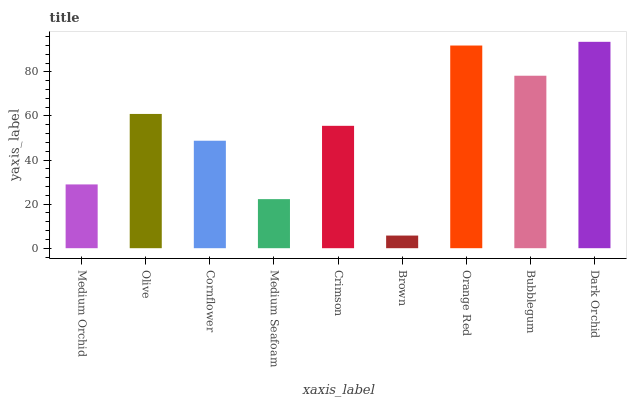Is Brown the minimum?
Answer yes or no. Yes. Is Dark Orchid the maximum?
Answer yes or no. Yes. Is Olive the minimum?
Answer yes or no. No. Is Olive the maximum?
Answer yes or no. No. Is Olive greater than Medium Orchid?
Answer yes or no. Yes. Is Medium Orchid less than Olive?
Answer yes or no. Yes. Is Medium Orchid greater than Olive?
Answer yes or no. No. Is Olive less than Medium Orchid?
Answer yes or no. No. Is Crimson the high median?
Answer yes or no. Yes. Is Crimson the low median?
Answer yes or no. Yes. Is Medium Seafoam the high median?
Answer yes or no. No. Is Olive the low median?
Answer yes or no. No. 